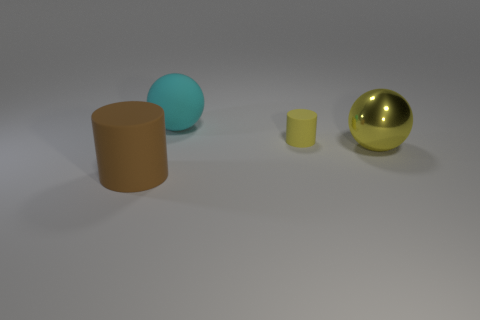How big is the rubber cylinder that is to the right of the rubber ball?
Ensure brevity in your answer.  Small. Do the cylinder that is behind the large shiny object and the sphere that is to the right of the big cyan thing have the same material?
Provide a short and direct response. No. There is a large thing that is the same color as the tiny rubber object; what is it made of?
Ensure brevity in your answer.  Metal. Is there anything else that is the same size as the yellow cylinder?
Ensure brevity in your answer.  No. What number of other objects are there of the same color as the metal object?
Your answer should be very brief. 1. The big rubber thing to the right of the big rubber cylinder has what shape?
Offer a terse response. Sphere. What number of objects are either metal things or big red rubber balls?
Make the answer very short. 1. Do the shiny thing and the thing that is behind the tiny yellow thing have the same size?
Provide a succinct answer. Yes. What number of other objects are there of the same material as the big yellow sphere?
Offer a terse response. 0. How many objects are big matte objects behind the brown thing or balls to the left of the metal thing?
Keep it short and to the point. 1. 